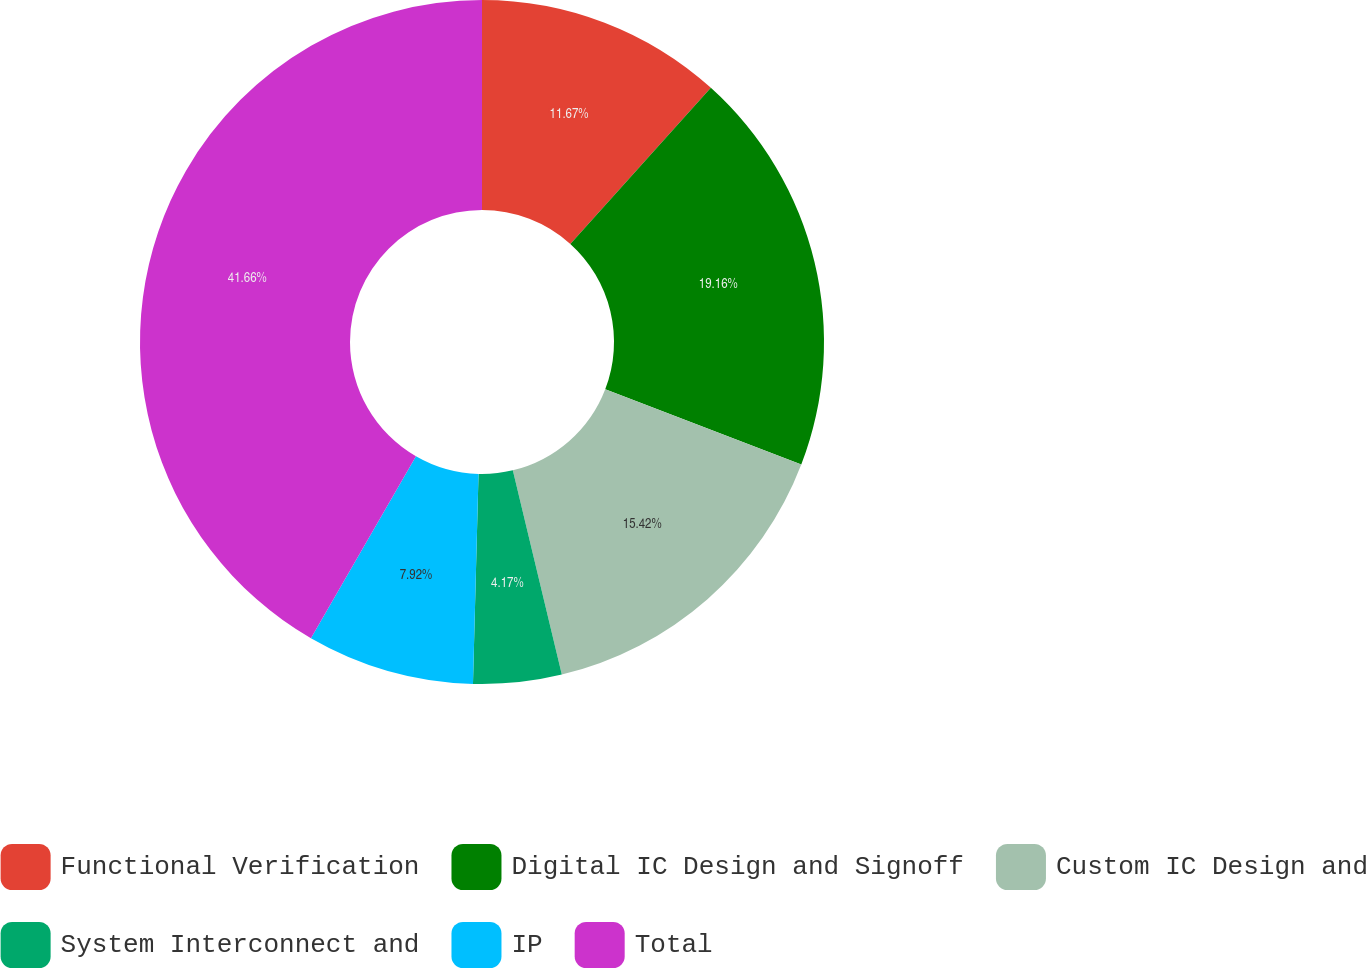Convert chart. <chart><loc_0><loc_0><loc_500><loc_500><pie_chart><fcel>Functional Verification<fcel>Digital IC Design and Signoff<fcel>Custom IC Design and<fcel>System Interconnect and<fcel>IP<fcel>Total<nl><fcel>11.67%<fcel>19.17%<fcel>15.42%<fcel>4.17%<fcel>7.92%<fcel>41.67%<nl></chart> 